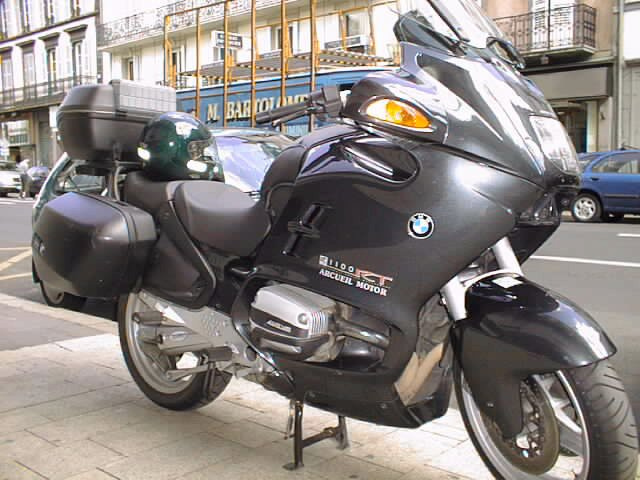Identify the text contained in this image. M BAR MOTOR ARCUEIL 1100 